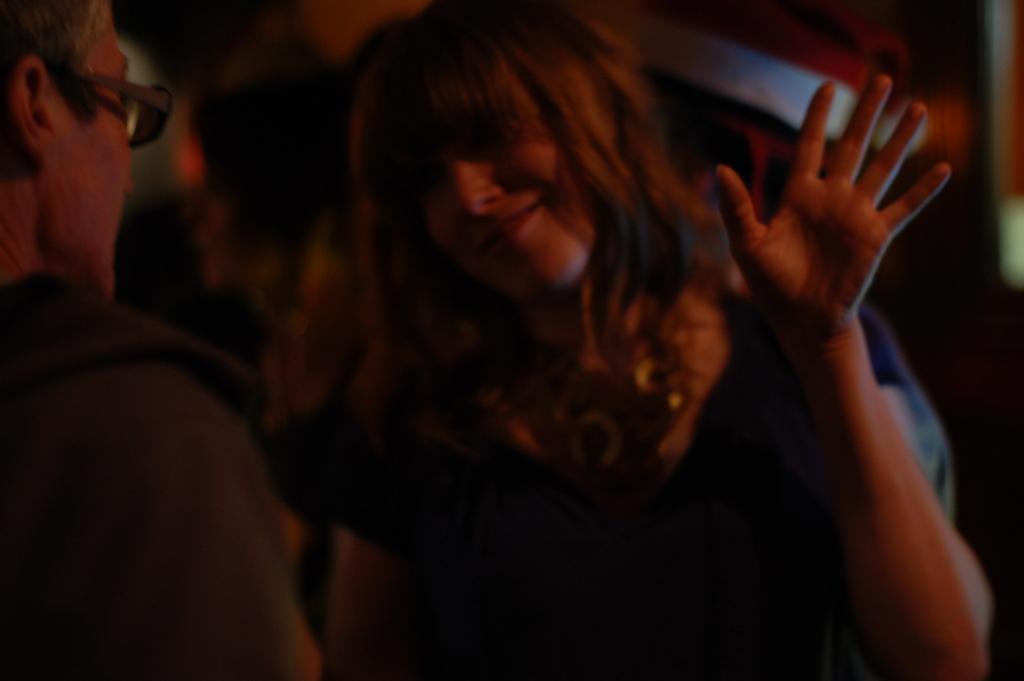Please provide a concise description of this image. In the picture we can see a man and a woman standing and looking at each other and woman is smiling and showing her hand and she is in a loose hair. 